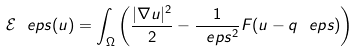<formula> <loc_0><loc_0><loc_500><loc_500>\mathcal { E } ^ { \ } e p s ( u ) = \int _ { \Omega } \left ( \frac { | \nabla u | ^ { 2 } } { 2 } - \frac { 1 } { \ e p s ^ { 2 } } F ( u - q ^ { \ } e p s ) \right )</formula> 